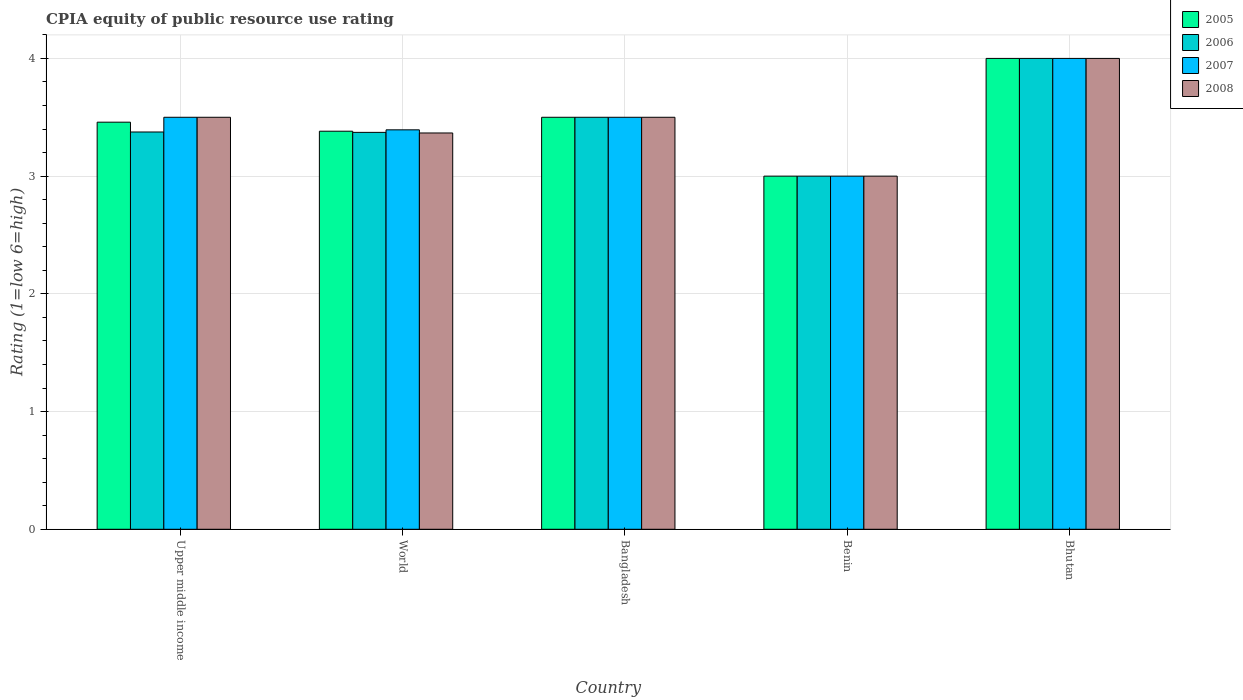Are the number of bars per tick equal to the number of legend labels?
Your answer should be very brief. Yes. How many bars are there on the 5th tick from the left?
Provide a short and direct response. 4. What is the label of the 1st group of bars from the left?
Offer a terse response. Upper middle income. In how many cases, is the number of bars for a given country not equal to the number of legend labels?
Offer a very short reply. 0. What is the CPIA rating in 2007 in Benin?
Your answer should be very brief. 3. In which country was the CPIA rating in 2008 maximum?
Make the answer very short. Bhutan. In which country was the CPIA rating in 2006 minimum?
Your answer should be compact. Benin. What is the total CPIA rating in 2005 in the graph?
Provide a succinct answer. 17.34. What is the difference between the CPIA rating in 2007 in Bangladesh and that in World?
Your answer should be compact. 0.11. What is the difference between the CPIA rating in 2005 in World and the CPIA rating in 2008 in Benin?
Provide a succinct answer. 0.38. What is the average CPIA rating in 2006 per country?
Offer a very short reply. 3.45. What is the ratio of the CPIA rating in 2008 in Upper middle income to that in World?
Provide a succinct answer. 1.04. What is the difference between the highest and the second highest CPIA rating in 2006?
Give a very brief answer. -0.12. What does the 1st bar from the right in World represents?
Your answer should be very brief. 2008. Is it the case that in every country, the sum of the CPIA rating in 2007 and CPIA rating in 2005 is greater than the CPIA rating in 2006?
Give a very brief answer. Yes. How many countries are there in the graph?
Your answer should be very brief. 5. Does the graph contain any zero values?
Keep it short and to the point. No. Does the graph contain grids?
Provide a succinct answer. Yes. Where does the legend appear in the graph?
Provide a short and direct response. Top right. How are the legend labels stacked?
Provide a short and direct response. Vertical. What is the title of the graph?
Offer a very short reply. CPIA equity of public resource use rating. Does "2006" appear as one of the legend labels in the graph?
Ensure brevity in your answer.  Yes. What is the Rating (1=low 6=high) in 2005 in Upper middle income?
Your answer should be compact. 3.46. What is the Rating (1=low 6=high) of 2006 in Upper middle income?
Offer a very short reply. 3.38. What is the Rating (1=low 6=high) of 2007 in Upper middle income?
Provide a succinct answer. 3.5. What is the Rating (1=low 6=high) in 2005 in World?
Make the answer very short. 3.38. What is the Rating (1=low 6=high) of 2006 in World?
Offer a terse response. 3.37. What is the Rating (1=low 6=high) of 2007 in World?
Your response must be concise. 3.39. What is the Rating (1=low 6=high) in 2008 in World?
Your response must be concise. 3.37. What is the Rating (1=low 6=high) in 2006 in Bangladesh?
Provide a succinct answer. 3.5. What is the Rating (1=low 6=high) of 2008 in Bangladesh?
Offer a terse response. 3.5. What is the Rating (1=low 6=high) in 2005 in Benin?
Your response must be concise. 3. What is the Rating (1=low 6=high) of 2008 in Benin?
Provide a succinct answer. 3. Across all countries, what is the maximum Rating (1=low 6=high) of 2005?
Provide a short and direct response. 4. Across all countries, what is the maximum Rating (1=low 6=high) of 2006?
Provide a succinct answer. 4. Across all countries, what is the maximum Rating (1=low 6=high) in 2007?
Provide a succinct answer. 4. Across all countries, what is the maximum Rating (1=low 6=high) in 2008?
Your response must be concise. 4. Across all countries, what is the minimum Rating (1=low 6=high) in 2008?
Your answer should be compact. 3. What is the total Rating (1=low 6=high) of 2005 in the graph?
Offer a terse response. 17.34. What is the total Rating (1=low 6=high) in 2006 in the graph?
Your response must be concise. 17.25. What is the total Rating (1=low 6=high) in 2007 in the graph?
Give a very brief answer. 17.39. What is the total Rating (1=low 6=high) of 2008 in the graph?
Offer a terse response. 17.37. What is the difference between the Rating (1=low 6=high) in 2005 in Upper middle income and that in World?
Your response must be concise. 0.08. What is the difference between the Rating (1=low 6=high) of 2006 in Upper middle income and that in World?
Your answer should be very brief. 0. What is the difference between the Rating (1=low 6=high) in 2007 in Upper middle income and that in World?
Provide a short and direct response. 0.11. What is the difference between the Rating (1=low 6=high) in 2008 in Upper middle income and that in World?
Your answer should be compact. 0.13. What is the difference between the Rating (1=low 6=high) of 2005 in Upper middle income and that in Bangladesh?
Your answer should be compact. -0.04. What is the difference between the Rating (1=low 6=high) of 2006 in Upper middle income and that in Bangladesh?
Offer a terse response. -0.12. What is the difference between the Rating (1=low 6=high) of 2007 in Upper middle income and that in Bangladesh?
Make the answer very short. 0. What is the difference between the Rating (1=low 6=high) in 2005 in Upper middle income and that in Benin?
Ensure brevity in your answer.  0.46. What is the difference between the Rating (1=low 6=high) of 2005 in Upper middle income and that in Bhutan?
Your response must be concise. -0.54. What is the difference between the Rating (1=low 6=high) in 2006 in Upper middle income and that in Bhutan?
Offer a terse response. -0.62. What is the difference between the Rating (1=low 6=high) of 2008 in Upper middle income and that in Bhutan?
Provide a short and direct response. -0.5. What is the difference between the Rating (1=low 6=high) in 2005 in World and that in Bangladesh?
Ensure brevity in your answer.  -0.12. What is the difference between the Rating (1=low 6=high) in 2006 in World and that in Bangladesh?
Offer a terse response. -0.13. What is the difference between the Rating (1=low 6=high) of 2007 in World and that in Bangladesh?
Your answer should be compact. -0.11. What is the difference between the Rating (1=low 6=high) in 2008 in World and that in Bangladesh?
Make the answer very short. -0.13. What is the difference between the Rating (1=low 6=high) in 2005 in World and that in Benin?
Your answer should be compact. 0.38. What is the difference between the Rating (1=low 6=high) of 2006 in World and that in Benin?
Your answer should be very brief. 0.37. What is the difference between the Rating (1=low 6=high) in 2007 in World and that in Benin?
Make the answer very short. 0.39. What is the difference between the Rating (1=low 6=high) of 2008 in World and that in Benin?
Offer a very short reply. 0.37. What is the difference between the Rating (1=low 6=high) of 2005 in World and that in Bhutan?
Your answer should be very brief. -0.62. What is the difference between the Rating (1=low 6=high) of 2006 in World and that in Bhutan?
Give a very brief answer. -0.63. What is the difference between the Rating (1=low 6=high) in 2007 in World and that in Bhutan?
Ensure brevity in your answer.  -0.61. What is the difference between the Rating (1=low 6=high) in 2008 in World and that in Bhutan?
Provide a succinct answer. -0.63. What is the difference between the Rating (1=low 6=high) in 2005 in Bangladesh and that in Benin?
Keep it short and to the point. 0.5. What is the difference between the Rating (1=low 6=high) in 2006 in Bangladesh and that in Benin?
Make the answer very short. 0.5. What is the difference between the Rating (1=low 6=high) in 2007 in Bangladesh and that in Benin?
Offer a terse response. 0.5. What is the difference between the Rating (1=low 6=high) of 2006 in Bangladesh and that in Bhutan?
Provide a short and direct response. -0.5. What is the difference between the Rating (1=low 6=high) of 2008 in Bangladesh and that in Bhutan?
Provide a succinct answer. -0.5. What is the difference between the Rating (1=low 6=high) in 2005 in Benin and that in Bhutan?
Keep it short and to the point. -1. What is the difference between the Rating (1=low 6=high) in 2005 in Upper middle income and the Rating (1=low 6=high) in 2006 in World?
Provide a succinct answer. 0.09. What is the difference between the Rating (1=low 6=high) of 2005 in Upper middle income and the Rating (1=low 6=high) of 2007 in World?
Ensure brevity in your answer.  0.07. What is the difference between the Rating (1=low 6=high) in 2005 in Upper middle income and the Rating (1=low 6=high) in 2008 in World?
Make the answer very short. 0.09. What is the difference between the Rating (1=low 6=high) in 2006 in Upper middle income and the Rating (1=low 6=high) in 2007 in World?
Your response must be concise. -0.02. What is the difference between the Rating (1=low 6=high) in 2006 in Upper middle income and the Rating (1=low 6=high) in 2008 in World?
Provide a short and direct response. 0.01. What is the difference between the Rating (1=low 6=high) in 2007 in Upper middle income and the Rating (1=low 6=high) in 2008 in World?
Ensure brevity in your answer.  0.13. What is the difference between the Rating (1=low 6=high) in 2005 in Upper middle income and the Rating (1=low 6=high) in 2006 in Bangladesh?
Provide a short and direct response. -0.04. What is the difference between the Rating (1=low 6=high) in 2005 in Upper middle income and the Rating (1=low 6=high) in 2007 in Bangladesh?
Your answer should be very brief. -0.04. What is the difference between the Rating (1=low 6=high) in 2005 in Upper middle income and the Rating (1=low 6=high) in 2008 in Bangladesh?
Keep it short and to the point. -0.04. What is the difference between the Rating (1=low 6=high) of 2006 in Upper middle income and the Rating (1=low 6=high) of 2007 in Bangladesh?
Make the answer very short. -0.12. What is the difference between the Rating (1=low 6=high) of 2006 in Upper middle income and the Rating (1=low 6=high) of 2008 in Bangladesh?
Give a very brief answer. -0.12. What is the difference between the Rating (1=low 6=high) in 2007 in Upper middle income and the Rating (1=low 6=high) in 2008 in Bangladesh?
Offer a terse response. 0. What is the difference between the Rating (1=low 6=high) in 2005 in Upper middle income and the Rating (1=low 6=high) in 2006 in Benin?
Offer a very short reply. 0.46. What is the difference between the Rating (1=low 6=high) in 2005 in Upper middle income and the Rating (1=low 6=high) in 2007 in Benin?
Your answer should be compact. 0.46. What is the difference between the Rating (1=low 6=high) in 2005 in Upper middle income and the Rating (1=low 6=high) in 2008 in Benin?
Ensure brevity in your answer.  0.46. What is the difference between the Rating (1=low 6=high) in 2006 in Upper middle income and the Rating (1=low 6=high) in 2007 in Benin?
Provide a short and direct response. 0.38. What is the difference between the Rating (1=low 6=high) in 2006 in Upper middle income and the Rating (1=low 6=high) in 2008 in Benin?
Your answer should be very brief. 0.38. What is the difference between the Rating (1=low 6=high) of 2005 in Upper middle income and the Rating (1=low 6=high) of 2006 in Bhutan?
Make the answer very short. -0.54. What is the difference between the Rating (1=low 6=high) in 2005 in Upper middle income and the Rating (1=low 6=high) in 2007 in Bhutan?
Your answer should be compact. -0.54. What is the difference between the Rating (1=low 6=high) in 2005 in Upper middle income and the Rating (1=low 6=high) in 2008 in Bhutan?
Give a very brief answer. -0.54. What is the difference between the Rating (1=low 6=high) in 2006 in Upper middle income and the Rating (1=low 6=high) in 2007 in Bhutan?
Ensure brevity in your answer.  -0.62. What is the difference between the Rating (1=low 6=high) in 2006 in Upper middle income and the Rating (1=low 6=high) in 2008 in Bhutan?
Your answer should be compact. -0.62. What is the difference between the Rating (1=low 6=high) of 2007 in Upper middle income and the Rating (1=low 6=high) of 2008 in Bhutan?
Your answer should be compact. -0.5. What is the difference between the Rating (1=low 6=high) of 2005 in World and the Rating (1=low 6=high) of 2006 in Bangladesh?
Your answer should be compact. -0.12. What is the difference between the Rating (1=low 6=high) of 2005 in World and the Rating (1=low 6=high) of 2007 in Bangladesh?
Offer a very short reply. -0.12. What is the difference between the Rating (1=low 6=high) of 2005 in World and the Rating (1=low 6=high) of 2008 in Bangladesh?
Provide a succinct answer. -0.12. What is the difference between the Rating (1=low 6=high) in 2006 in World and the Rating (1=low 6=high) in 2007 in Bangladesh?
Offer a terse response. -0.13. What is the difference between the Rating (1=low 6=high) in 2006 in World and the Rating (1=low 6=high) in 2008 in Bangladesh?
Your answer should be compact. -0.13. What is the difference between the Rating (1=low 6=high) in 2007 in World and the Rating (1=low 6=high) in 2008 in Bangladesh?
Offer a very short reply. -0.11. What is the difference between the Rating (1=low 6=high) of 2005 in World and the Rating (1=low 6=high) of 2006 in Benin?
Your answer should be very brief. 0.38. What is the difference between the Rating (1=low 6=high) of 2005 in World and the Rating (1=low 6=high) of 2007 in Benin?
Keep it short and to the point. 0.38. What is the difference between the Rating (1=low 6=high) of 2005 in World and the Rating (1=low 6=high) of 2008 in Benin?
Offer a very short reply. 0.38. What is the difference between the Rating (1=low 6=high) in 2006 in World and the Rating (1=low 6=high) in 2007 in Benin?
Make the answer very short. 0.37. What is the difference between the Rating (1=low 6=high) of 2006 in World and the Rating (1=low 6=high) of 2008 in Benin?
Offer a very short reply. 0.37. What is the difference between the Rating (1=low 6=high) in 2007 in World and the Rating (1=low 6=high) in 2008 in Benin?
Provide a short and direct response. 0.39. What is the difference between the Rating (1=low 6=high) of 2005 in World and the Rating (1=low 6=high) of 2006 in Bhutan?
Offer a terse response. -0.62. What is the difference between the Rating (1=low 6=high) in 2005 in World and the Rating (1=low 6=high) in 2007 in Bhutan?
Your answer should be compact. -0.62. What is the difference between the Rating (1=low 6=high) of 2005 in World and the Rating (1=low 6=high) of 2008 in Bhutan?
Offer a terse response. -0.62. What is the difference between the Rating (1=low 6=high) in 2006 in World and the Rating (1=low 6=high) in 2007 in Bhutan?
Offer a terse response. -0.63. What is the difference between the Rating (1=low 6=high) in 2006 in World and the Rating (1=low 6=high) in 2008 in Bhutan?
Your response must be concise. -0.63. What is the difference between the Rating (1=low 6=high) of 2007 in World and the Rating (1=low 6=high) of 2008 in Bhutan?
Provide a succinct answer. -0.61. What is the difference between the Rating (1=low 6=high) of 2005 in Bangladesh and the Rating (1=low 6=high) of 2008 in Benin?
Your response must be concise. 0.5. What is the difference between the Rating (1=low 6=high) in 2007 in Bangladesh and the Rating (1=low 6=high) in 2008 in Benin?
Offer a terse response. 0.5. What is the difference between the Rating (1=low 6=high) in 2005 in Bangladesh and the Rating (1=low 6=high) in 2006 in Bhutan?
Offer a very short reply. -0.5. What is the difference between the Rating (1=low 6=high) of 2006 in Bangladesh and the Rating (1=low 6=high) of 2007 in Bhutan?
Provide a short and direct response. -0.5. What is the difference between the Rating (1=low 6=high) in 2006 in Bangladesh and the Rating (1=low 6=high) in 2008 in Bhutan?
Make the answer very short. -0.5. What is the difference between the Rating (1=low 6=high) in 2005 in Benin and the Rating (1=low 6=high) in 2006 in Bhutan?
Provide a short and direct response. -1. What is the difference between the Rating (1=low 6=high) in 2006 in Benin and the Rating (1=low 6=high) in 2008 in Bhutan?
Offer a very short reply. -1. What is the difference between the Rating (1=low 6=high) in 2007 in Benin and the Rating (1=low 6=high) in 2008 in Bhutan?
Offer a terse response. -1. What is the average Rating (1=low 6=high) of 2005 per country?
Make the answer very short. 3.47. What is the average Rating (1=low 6=high) in 2006 per country?
Offer a terse response. 3.45. What is the average Rating (1=low 6=high) in 2007 per country?
Your answer should be compact. 3.48. What is the average Rating (1=low 6=high) of 2008 per country?
Give a very brief answer. 3.47. What is the difference between the Rating (1=low 6=high) of 2005 and Rating (1=low 6=high) of 2006 in Upper middle income?
Provide a succinct answer. 0.08. What is the difference between the Rating (1=low 6=high) in 2005 and Rating (1=low 6=high) in 2007 in Upper middle income?
Offer a terse response. -0.04. What is the difference between the Rating (1=low 6=high) of 2005 and Rating (1=low 6=high) of 2008 in Upper middle income?
Offer a very short reply. -0.04. What is the difference between the Rating (1=low 6=high) of 2006 and Rating (1=low 6=high) of 2007 in Upper middle income?
Offer a very short reply. -0.12. What is the difference between the Rating (1=low 6=high) in 2006 and Rating (1=low 6=high) in 2008 in Upper middle income?
Your response must be concise. -0.12. What is the difference between the Rating (1=low 6=high) of 2007 and Rating (1=low 6=high) of 2008 in Upper middle income?
Provide a succinct answer. 0. What is the difference between the Rating (1=low 6=high) of 2005 and Rating (1=low 6=high) of 2006 in World?
Offer a terse response. 0.01. What is the difference between the Rating (1=low 6=high) in 2005 and Rating (1=low 6=high) in 2007 in World?
Provide a short and direct response. -0.01. What is the difference between the Rating (1=low 6=high) of 2005 and Rating (1=low 6=high) of 2008 in World?
Offer a terse response. 0.01. What is the difference between the Rating (1=low 6=high) in 2006 and Rating (1=low 6=high) in 2007 in World?
Your response must be concise. -0.02. What is the difference between the Rating (1=low 6=high) of 2006 and Rating (1=low 6=high) of 2008 in World?
Offer a terse response. 0.01. What is the difference between the Rating (1=low 6=high) in 2007 and Rating (1=low 6=high) in 2008 in World?
Offer a terse response. 0.03. What is the difference between the Rating (1=low 6=high) of 2005 and Rating (1=low 6=high) of 2007 in Bangladesh?
Ensure brevity in your answer.  0. What is the difference between the Rating (1=low 6=high) in 2006 and Rating (1=low 6=high) in 2007 in Bangladesh?
Your answer should be compact. 0. What is the difference between the Rating (1=low 6=high) of 2006 and Rating (1=low 6=high) of 2008 in Bangladesh?
Ensure brevity in your answer.  0. What is the difference between the Rating (1=low 6=high) of 2007 and Rating (1=low 6=high) of 2008 in Bangladesh?
Offer a terse response. 0. What is the difference between the Rating (1=low 6=high) of 2005 and Rating (1=low 6=high) of 2006 in Benin?
Your answer should be compact. 0. What is the difference between the Rating (1=low 6=high) of 2005 and Rating (1=low 6=high) of 2007 in Benin?
Offer a terse response. 0. What is the difference between the Rating (1=low 6=high) in 2005 and Rating (1=low 6=high) in 2008 in Benin?
Keep it short and to the point. 0. What is the difference between the Rating (1=low 6=high) in 2006 and Rating (1=low 6=high) in 2008 in Benin?
Your answer should be very brief. 0. What is the difference between the Rating (1=low 6=high) of 2007 and Rating (1=low 6=high) of 2008 in Benin?
Give a very brief answer. 0. What is the difference between the Rating (1=low 6=high) in 2005 and Rating (1=low 6=high) in 2006 in Bhutan?
Offer a terse response. 0. What is the difference between the Rating (1=low 6=high) of 2005 and Rating (1=low 6=high) of 2008 in Bhutan?
Make the answer very short. 0. What is the difference between the Rating (1=low 6=high) in 2007 and Rating (1=low 6=high) in 2008 in Bhutan?
Ensure brevity in your answer.  0. What is the ratio of the Rating (1=low 6=high) in 2005 in Upper middle income to that in World?
Your answer should be very brief. 1.02. What is the ratio of the Rating (1=low 6=high) of 2006 in Upper middle income to that in World?
Your response must be concise. 1. What is the ratio of the Rating (1=low 6=high) in 2007 in Upper middle income to that in World?
Keep it short and to the point. 1.03. What is the ratio of the Rating (1=low 6=high) of 2008 in Upper middle income to that in World?
Give a very brief answer. 1.04. What is the ratio of the Rating (1=low 6=high) in 2006 in Upper middle income to that in Bangladesh?
Make the answer very short. 0.96. What is the ratio of the Rating (1=low 6=high) of 2007 in Upper middle income to that in Bangladesh?
Provide a succinct answer. 1. What is the ratio of the Rating (1=low 6=high) of 2005 in Upper middle income to that in Benin?
Provide a short and direct response. 1.15. What is the ratio of the Rating (1=low 6=high) of 2006 in Upper middle income to that in Benin?
Give a very brief answer. 1.12. What is the ratio of the Rating (1=low 6=high) of 2007 in Upper middle income to that in Benin?
Keep it short and to the point. 1.17. What is the ratio of the Rating (1=low 6=high) in 2005 in Upper middle income to that in Bhutan?
Provide a succinct answer. 0.86. What is the ratio of the Rating (1=low 6=high) in 2006 in Upper middle income to that in Bhutan?
Your answer should be very brief. 0.84. What is the ratio of the Rating (1=low 6=high) of 2007 in Upper middle income to that in Bhutan?
Your response must be concise. 0.88. What is the ratio of the Rating (1=low 6=high) of 2005 in World to that in Bangladesh?
Make the answer very short. 0.97. What is the ratio of the Rating (1=low 6=high) of 2006 in World to that in Bangladesh?
Give a very brief answer. 0.96. What is the ratio of the Rating (1=low 6=high) in 2007 in World to that in Bangladesh?
Give a very brief answer. 0.97. What is the ratio of the Rating (1=low 6=high) in 2008 in World to that in Bangladesh?
Provide a succinct answer. 0.96. What is the ratio of the Rating (1=low 6=high) of 2005 in World to that in Benin?
Your answer should be very brief. 1.13. What is the ratio of the Rating (1=low 6=high) in 2006 in World to that in Benin?
Ensure brevity in your answer.  1.12. What is the ratio of the Rating (1=low 6=high) in 2007 in World to that in Benin?
Offer a very short reply. 1.13. What is the ratio of the Rating (1=low 6=high) in 2008 in World to that in Benin?
Offer a very short reply. 1.12. What is the ratio of the Rating (1=low 6=high) of 2005 in World to that in Bhutan?
Offer a very short reply. 0.85. What is the ratio of the Rating (1=low 6=high) in 2006 in World to that in Bhutan?
Provide a succinct answer. 0.84. What is the ratio of the Rating (1=low 6=high) of 2007 in World to that in Bhutan?
Keep it short and to the point. 0.85. What is the ratio of the Rating (1=low 6=high) in 2008 in World to that in Bhutan?
Provide a succinct answer. 0.84. What is the ratio of the Rating (1=low 6=high) of 2005 in Bangladesh to that in Benin?
Offer a terse response. 1.17. What is the ratio of the Rating (1=low 6=high) in 2006 in Bangladesh to that in Benin?
Ensure brevity in your answer.  1.17. What is the ratio of the Rating (1=low 6=high) in 2007 in Bangladesh to that in Benin?
Give a very brief answer. 1.17. What is the ratio of the Rating (1=low 6=high) in 2005 in Bangladesh to that in Bhutan?
Keep it short and to the point. 0.88. What is the ratio of the Rating (1=low 6=high) in 2006 in Bangladesh to that in Bhutan?
Make the answer very short. 0.88. What is the ratio of the Rating (1=low 6=high) in 2007 in Benin to that in Bhutan?
Make the answer very short. 0.75. What is the difference between the highest and the second highest Rating (1=low 6=high) in 2005?
Your response must be concise. 0.5. What is the difference between the highest and the second highest Rating (1=low 6=high) in 2006?
Keep it short and to the point. 0.5. What is the difference between the highest and the second highest Rating (1=low 6=high) in 2007?
Provide a succinct answer. 0.5. What is the difference between the highest and the lowest Rating (1=low 6=high) in 2007?
Keep it short and to the point. 1. 